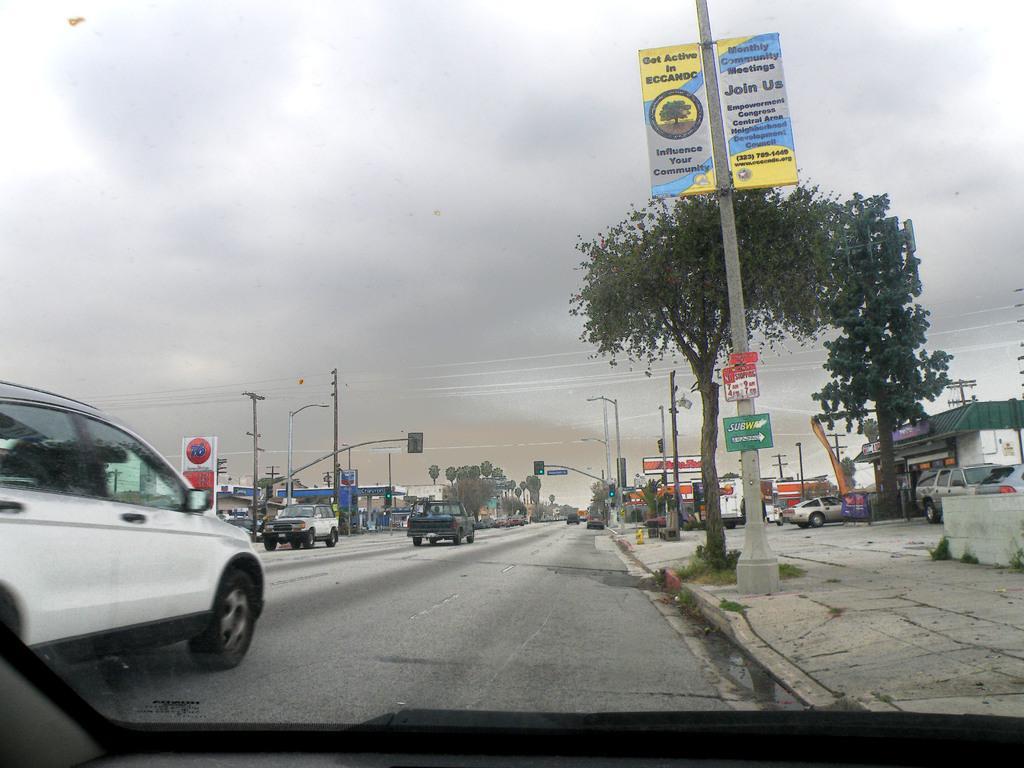Can you describe this image briefly? In this picture we can see vehicles on the ground, here we can see trees, traffic signals, posters, buildings, electric poles, wires and we can see sky in the background. 